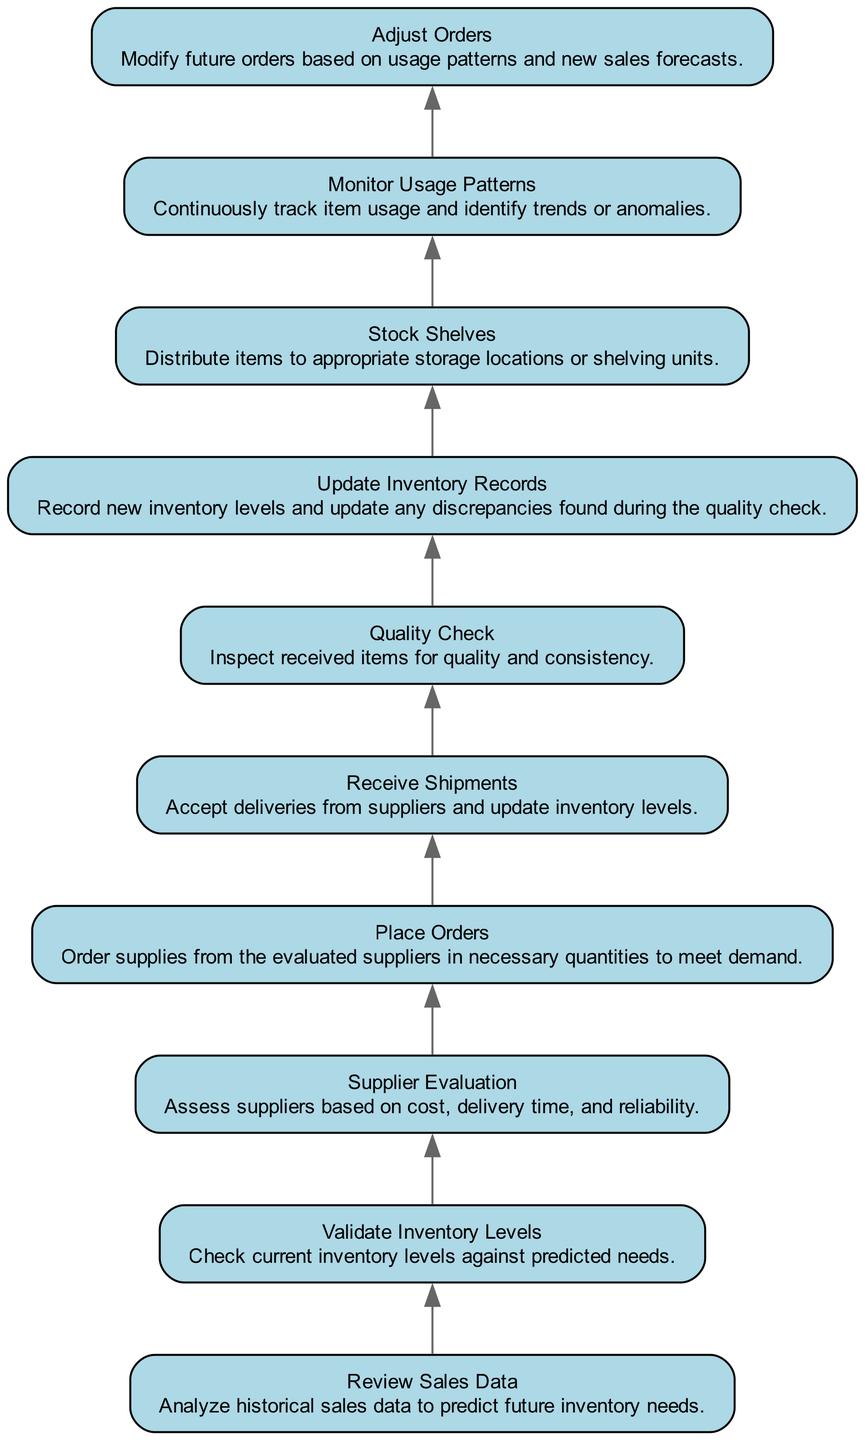What is the first step in the diagram? The first step in the diagram is "Review Sales Data," which has no dependencies and serves as the starting point for the inventory management process.
Answer: Review Sales Data How many nodes are in the diagram? By counting all the nodes present in the diagram, including each component from "Review Sales Data" to "Adjust Orders," there are a total of ten nodes.
Answer: 10 What is the last step in the diagram? The last step in the diagram is "Adjust Orders," indicating it is the concluding action after analyzing usage patterns.
Answer: Adjust Orders Which node has the most dependencies? The node "Update Inventory Records" has one dependency, which is "Quality Check," but all nodes that follow it essentially stem from previous steps, making it one of the significant points in the flow.
Answer: 1 What is the relationship between "Receive Shipments" and "Quality Check"? "Receive Shipments" directly precedes "Quality Check" in the flow, meaning "Quality Check" is dependent on the completion of "Receive Shipments."
Answer: Directly precedes In what order do shipments and quality checks occur? Shipments are received first, which is necessary before conducting quality checks to ensure the received items are satisfactory.
Answer: Shipments first, quality checks second What does the "Monitor Usage Patterns" step signify? This step signifies the ongoing process of tracking item usage, crucial for adjusting future orders based on demand trends.
Answer: Ongoing tracking of item usage Which node is reached after "Supplier Evaluation"? After "Supplier Evaluation," the next step is "Place Orders," indicating where orders for supplies are made based on supplier assessments.
Answer: Place Orders What triggers the "Adjust Orders" step? The "Adjust Orders" step is triggered by the findings from "Monitor Usage Patterns," where insights into usage trends influence future inventory orders.
Answer: Insights from usage patterns 